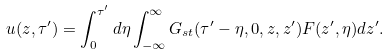Convert formula to latex. <formula><loc_0><loc_0><loc_500><loc_500>u ( z , \tau ^ { \prime } ) = \int _ { 0 } ^ { \tau ^ { \prime } } d \eta \int _ { - \infty } ^ { \infty } G _ { s t } ( \tau ^ { \prime } - \eta , 0 , z , z ^ { \prime } ) F ( z ^ { \prime } , \eta ) d z ^ { \prime } .</formula> 